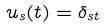Convert formula to latex. <formula><loc_0><loc_0><loc_500><loc_500>\ u _ { s } ( t ) = \delta _ { s t }</formula> 